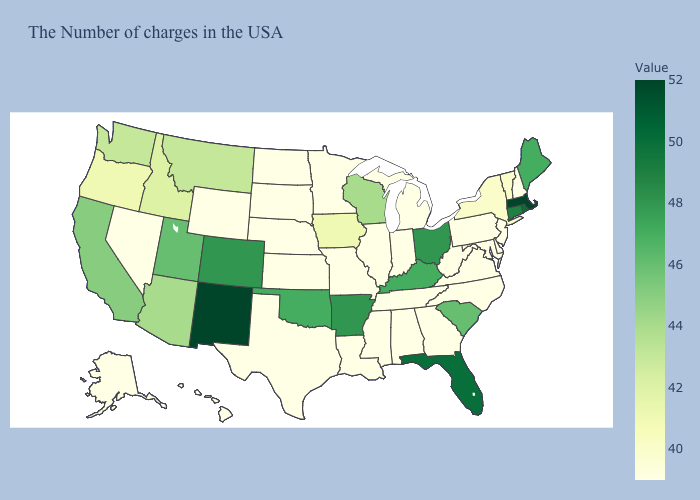Does Alaska have the lowest value in the West?
Quick response, please. Yes. Does Oregon have a higher value than New Jersey?
Be succinct. Yes. Does North Dakota have a lower value than Iowa?
Quick response, please. Yes. 